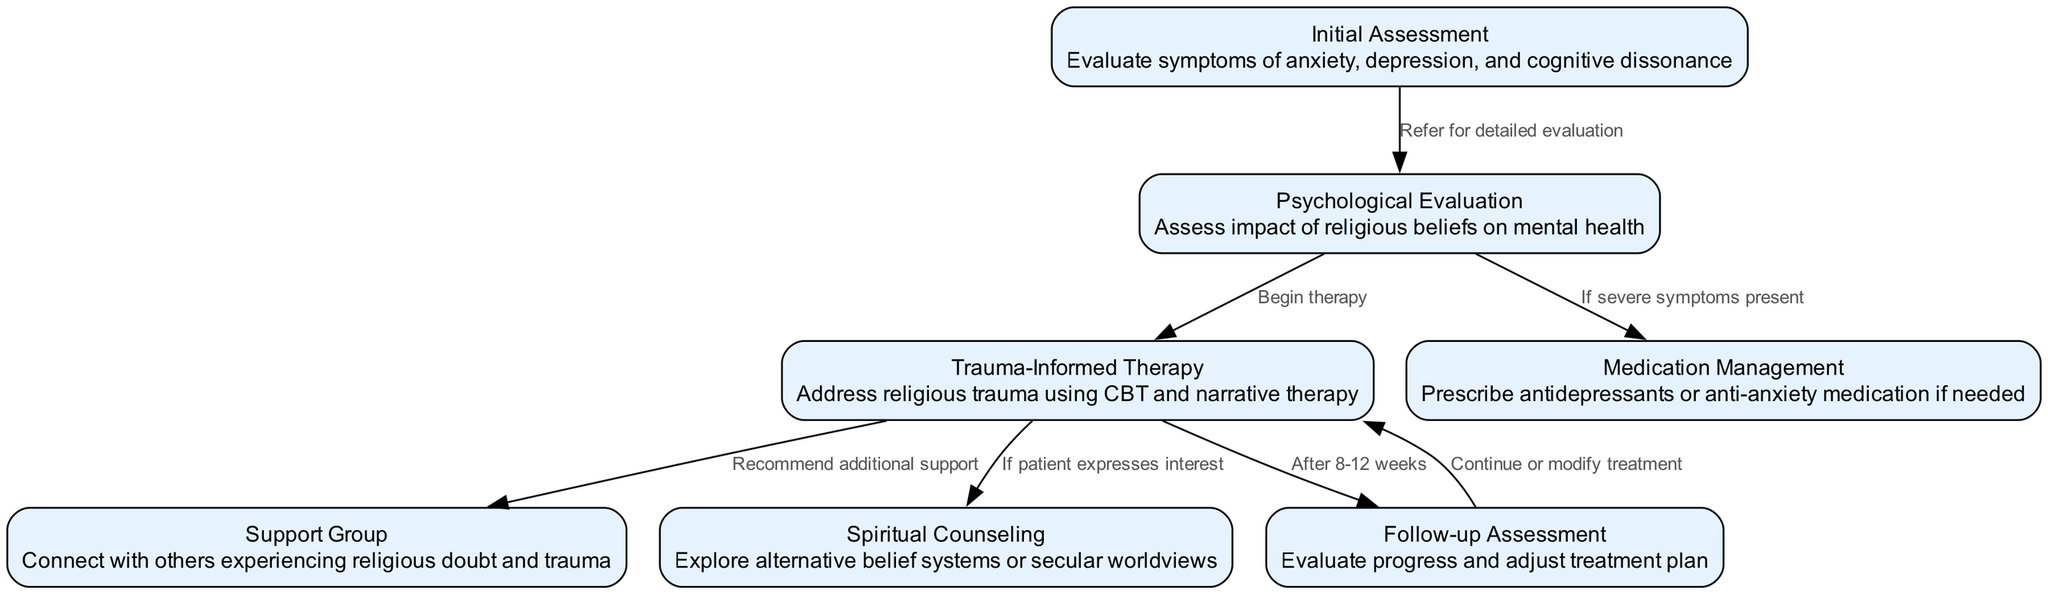What is the first step in the pathway? The first step in the clinical pathway is the "Initial Assessment," which involves evaluating symptoms of anxiety, depression, and cognitive dissonance.
Answer: Initial Assessment How many total nodes are there in the diagram? The diagram contains a total of 7 nodes that detail various steps in the diagnostic and treatment process for religious trauma syndrome.
Answer: 7 What is the purpose of the "Support Group" node? The "Support Group" node is designed to connect individuals who are experiencing similar feelings of religious doubt and trauma, providing additional emotional support during the recovery process.
Answer: Connect with others Which node leads to "Follow-up Assessment"? The "Follow-up Assessment" node is reached after the "Trauma-Informed Therapy" node, which evaluates progress and habits learned over an 8-12 week therapy period.
Answer: Trauma-Informed Therapy If severe symptoms are present after psychological evaluation, what step may be taken? If severe symptoms are present post-evaluation, "Medication Management" is a potential next step to prescribe antidepressants or anti-anxiety medications as needed.
Answer: Medication Management What is the relationship between "Trauma-Informed Therapy" and the "Spiritual Counseling" node? "Trauma-Informed Therapy" may lead to "Spiritual Counseling" if the patient expresses interest in exploring alternative belief systems or secular worldviews, indicating a possible connection to their healing process.
Answer: If patient expresses interest How many edges connect "Psychological Evaluation" to other nodes? The "Psychological Evaluation" node connects to 3 other nodes: "Trauma-Informed Therapy," "Medication Management," and "Initial Assessment," indicating the various pathways available after assessment.
Answer: 3 What do you do after completing "Follow-up Assessment"? After completing the "Follow-up Assessment," the next action generally involves a decision to either continue or modify the treatment based on the assessment results.
Answer: Continue or modify treatment 